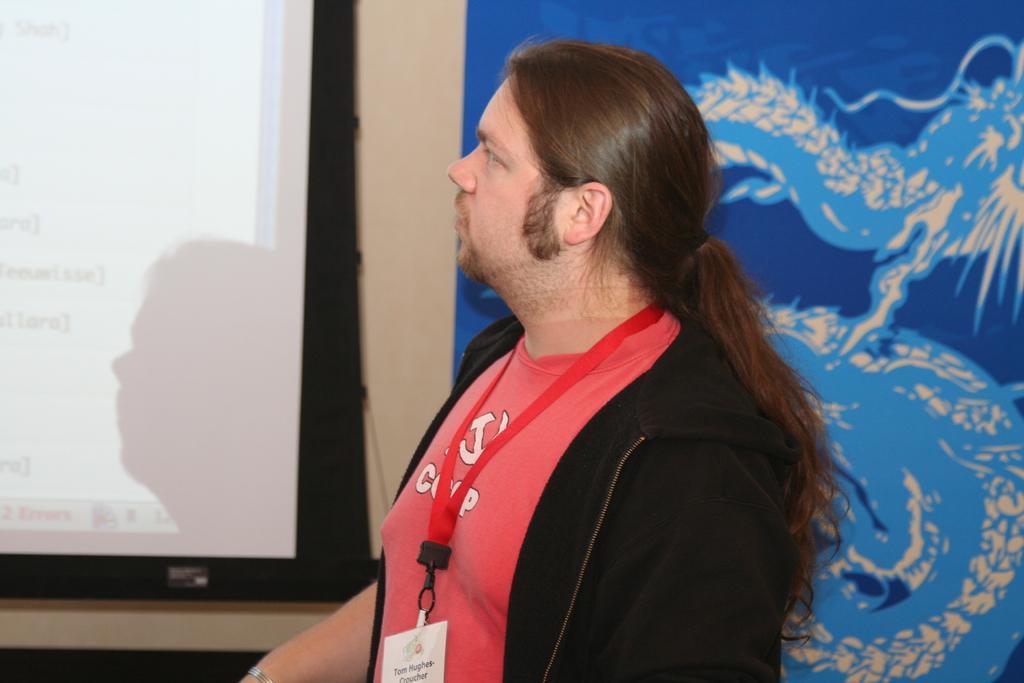Describe this image in one or two sentences. In this image, we can see a person wearing id card and in the background, there is a screen and there is a poster. 